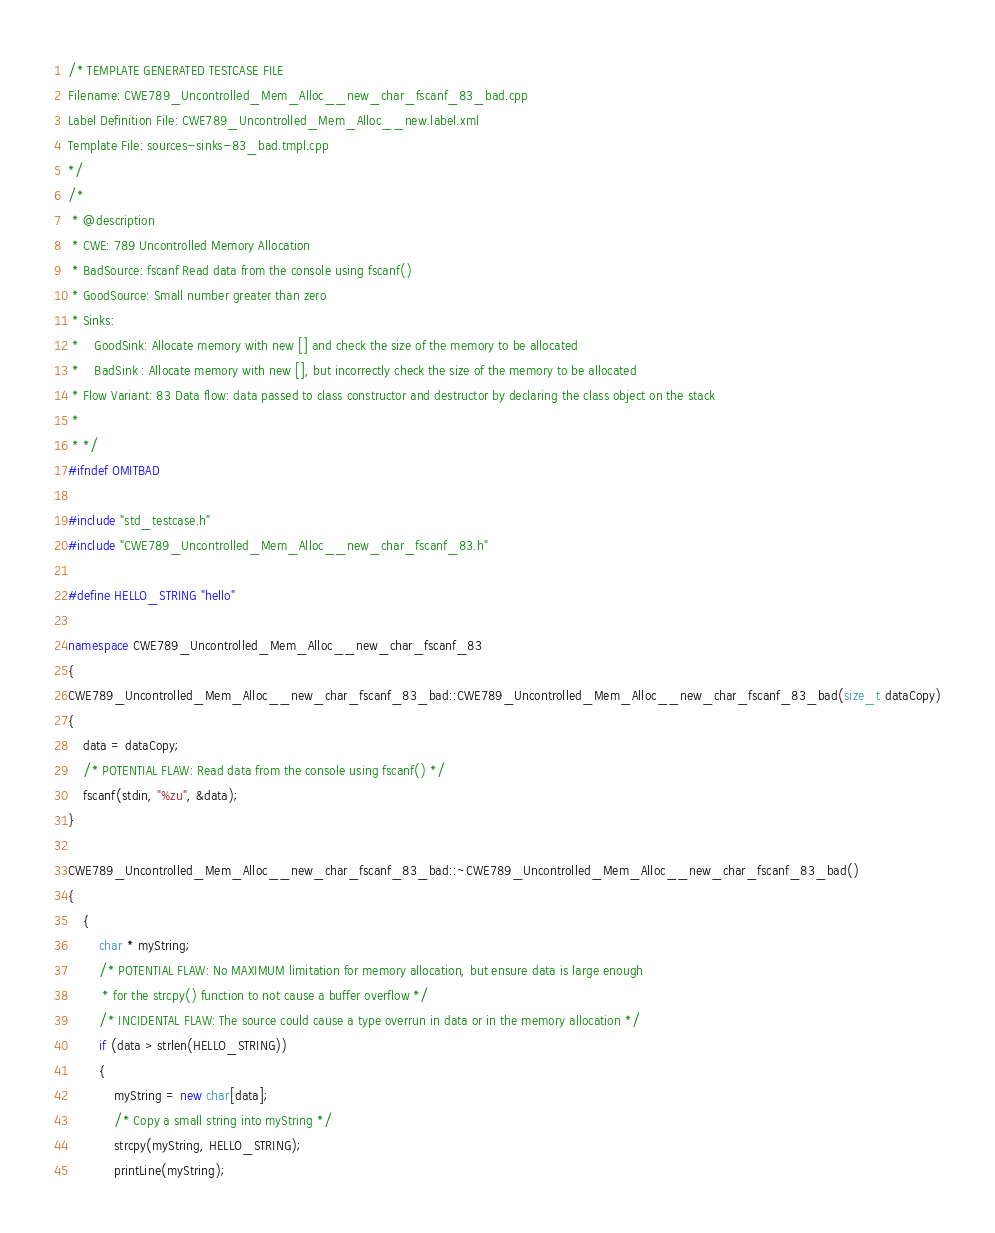Convert code to text. <code><loc_0><loc_0><loc_500><loc_500><_C++_>/* TEMPLATE GENERATED TESTCASE FILE
Filename: CWE789_Uncontrolled_Mem_Alloc__new_char_fscanf_83_bad.cpp
Label Definition File: CWE789_Uncontrolled_Mem_Alloc__new.label.xml
Template File: sources-sinks-83_bad.tmpl.cpp
*/
/*
 * @description
 * CWE: 789 Uncontrolled Memory Allocation
 * BadSource: fscanf Read data from the console using fscanf()
 * GoodSource: Small number greater than zero
 * Sinks:
 *    GoodSink: Allocate memory with new [] and check the size of the memory to be allocated
 *    BadSink : Allocate memory with new [], but incorrectly check the size of the memory to be allocated
 * Flow Variant: 83 Data flow: data passed to class constructor and destructor by declaring the class object on the stack
 *
 * */
#ifndef OMITBAD

#include "std_testcase.h"
#include "CWE789_Uncontrolled_Mem_Alloc__new_char_fscanf_83.h"

#define HELLO_STRING "hello"

namespace CWE789_Uncontrolled_Mem_Alloc__new_char_fscanf_83
{
CWE789_Uncontrolled_Mem_Alloc__new_char_fscanf_83_bad::CWE789_Uncontrolled_Mem_Alloc__new_char_fscanf_83_bad(size_t dataCopy)
{
    data = dataCopy;
    /* POTENTIAL FLAW: Read data from the console using fscanf() */
    fscanf(stdin, "%zu", &data);
}

CWE789_Uncontrolled_Mem_Alloc__new_char_fscanf_83_bad::~CWE789_Uncontrolled_Mem_Alloc__new_char_fscanf_83_bad()
{
    {
        char * myString;
        /* POTENTIAL FLAW: No MAXIMUM limitation for memory allocation, but ensure data is large enough
         * for the strcpy() function to not cause a buffer overflow */
        /* INCIDENTAL FLAW: The source could cause a type overrun in data or in the memory allocation */
        if (data > strlen(HELLO_STRING))
        {
            myString = new char[data];
            /* Copy a small string into myString */
            strcpy(myString, HELLO_STRING);
            printLine(myString);</code> 